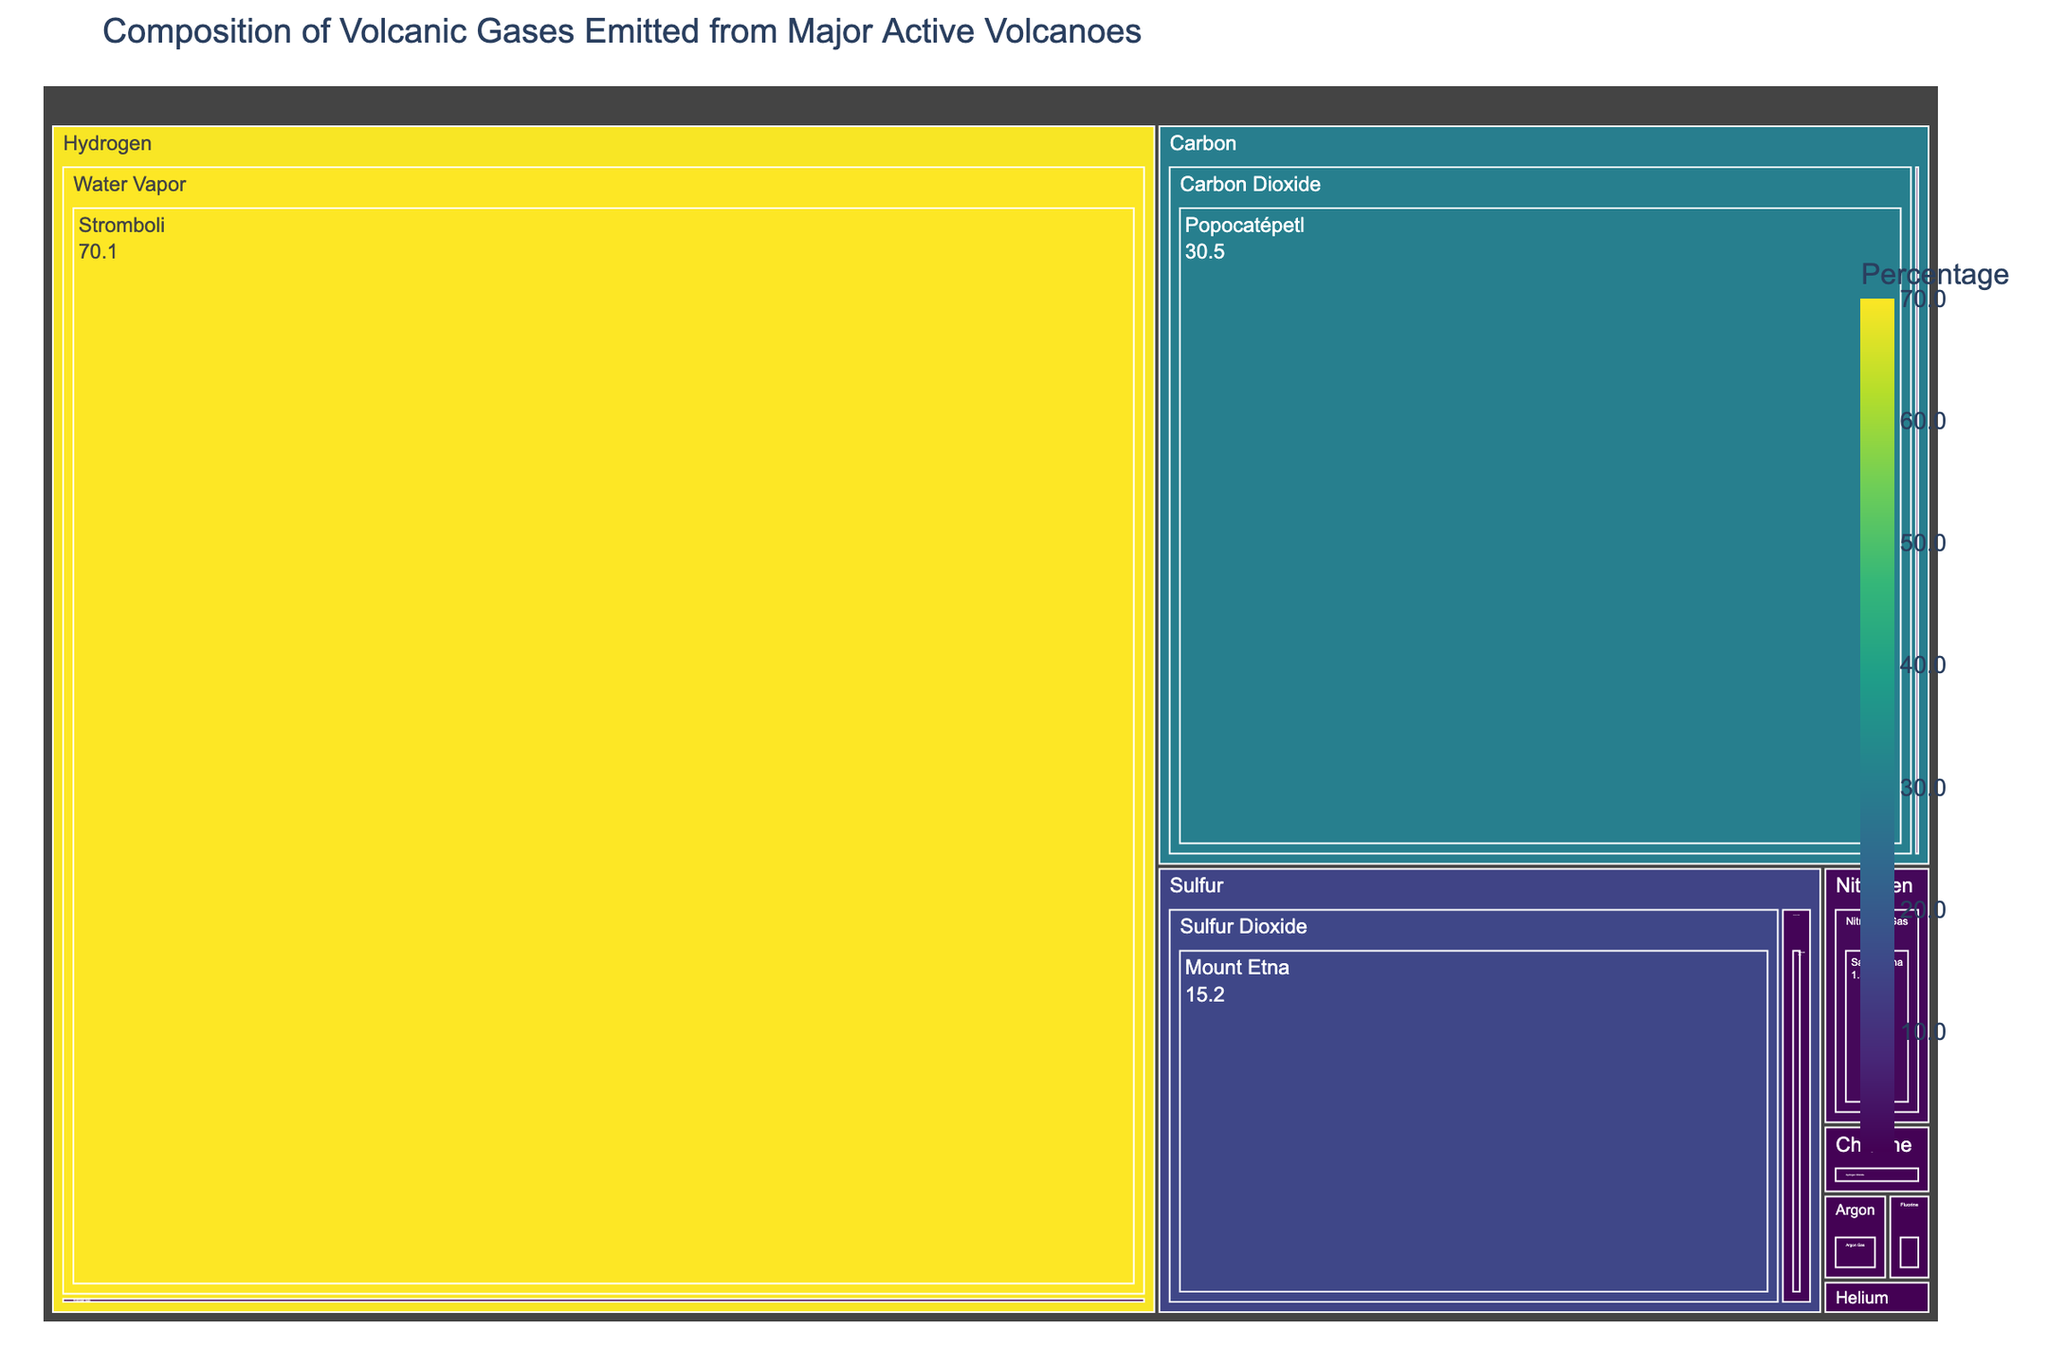What is the title of the treemap? The title is usually located at the top of the figure and provides a concise description of what the treemap represents. Here, the title mentioned is "Composition of Volcanic Gases Emitted from Major Active Volcanoes".
Answer: Composition of Volcanic Gases Emitted from Major Active Volcanoes Which gas has the highest percentage and from which volcano is it emitted? By examining the treemap, you will notice the largest section under a particular chemical element with the highest percentage. Water Vapor under Hydrogen emitted from Stromboli with 70.1% is the largest.
Answer: Water Vapor from Stromboli What is the percentage of Sulfur Dioxide emitted from Mount Etna? Look for the section labeled Sulfur Dioxide under the Sulfur category. The color intensity and value indicated should show the percentage.
Answer: 15.2% How many chemical elements are represented in the treemap? Each unique top-level category in the treemap represents a different chemical element. Count these categories to find the total number.
Answer: 8 Which volcano emits both Carbon Dioxide and Carbon Monoxide? Find the volcano listed under both Carbon Dioxide and Carbon Monoxide categories. Both will be under the Carbon element. Popocatépetl emits Carbon Dioxide and Mount Merapi emits Carbon Monoxide, no single volcano emits both gases.
Answer: None Which gas is emitted in the smallest percentage and from which volcano? Identify the smallest section in the treemap. Hydrogen Fluoride from Masaya is the smallest with 0.2%.
Answer: Hydrogen Fluoride from Masaya Compare the total percentage of gases emitted by Mount Etna and Kilauea. Which volcano emits more? Sum the percentages of all gases emitted by each of these two volcanoes. Mount Etna emits 15.2% Sulfur Dioxide; Kilauea emits 0.8% Hydrogen Sulfide. Compare these totals to see which is larger.
Answer: Mount Etna emits more What is the combined percentage of gases emitted by volcanoes categorized under Nitrogen and Argon elements? Locate the total percentages for elements Nitrogen (Nitrogen Gas, 1.5%) and Argon (Argon Gas, 0.3%). Sum these percentages.
Answer: 1.8% Compare the emission percentages of Hydrogen Chloride and Helium Gas. Which one has a higher percentage? Hydrogen Chloride under Chlorine has 0.4%, and Helium Gas under Helium has 0.2%. By comparing these numbers, Hydrogen Chloride has a higher percentage.
Answer: Hydrogen Chloride What is the average percentage of gases emitted by all volcanoes listed under the Carbon element? List the percentages of gases under the Carbon element: Carbon Dioxide (30.5%) and Carbon Monoxide (0.3%). Calculate the average: (30.5 + 0.3) / 2 = 15.4.
Answer: 15.4% 